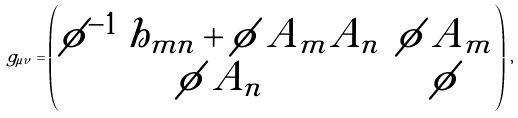Convert formula to latex. <formula><loc_0><loc_0><loc_500><loc_500>g _ { \mu \nu } = \begin{pmatrix} \phi ^ { - 1 } \, h _ { m n } + \phi \, A _ { m } A _ { n } & \phi \, A _ { m } \\ \phi \, A _ { n } & \phi \end{pmatrix} \, ,</formula> 